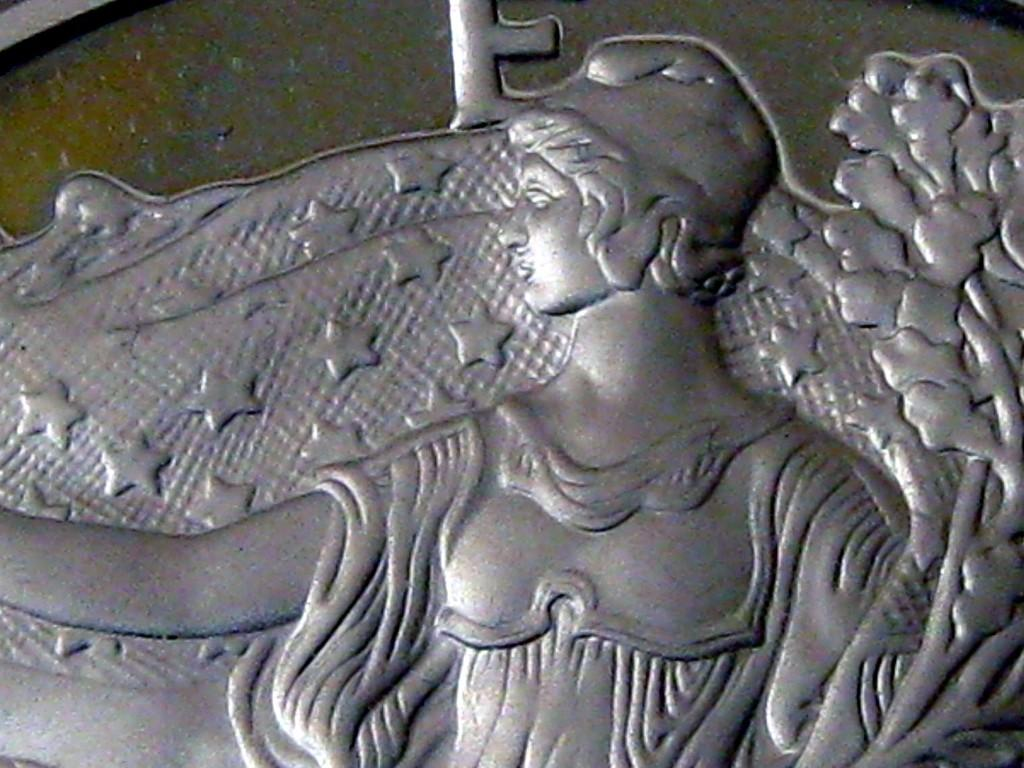What is the main subject in the foreground of the image? There is a model in the foreground of the image. What is the model placed on? The model is on a logo. What type of insurance policy is being advertised by the model in the image? There is no indication of an insurance policy or any advertisement in the image; it only features a model on a logo. Can you tell me where the stove is located in the image? There is no stove present in the image. 